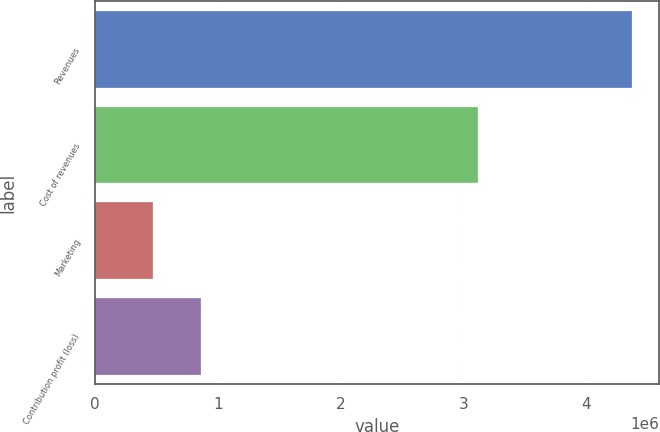<chart> <loc_0><loc_0><loc_500><loc_500><bar_chart><fcel>Revenues<fcel>Cost of revenues<fcel>Marketing<fcel>Contribution profit (loss)<nl><fcel>4.37456e+06<fcel>3.1172e+06<fcel>469942<fcel>860404<nl></chart> 